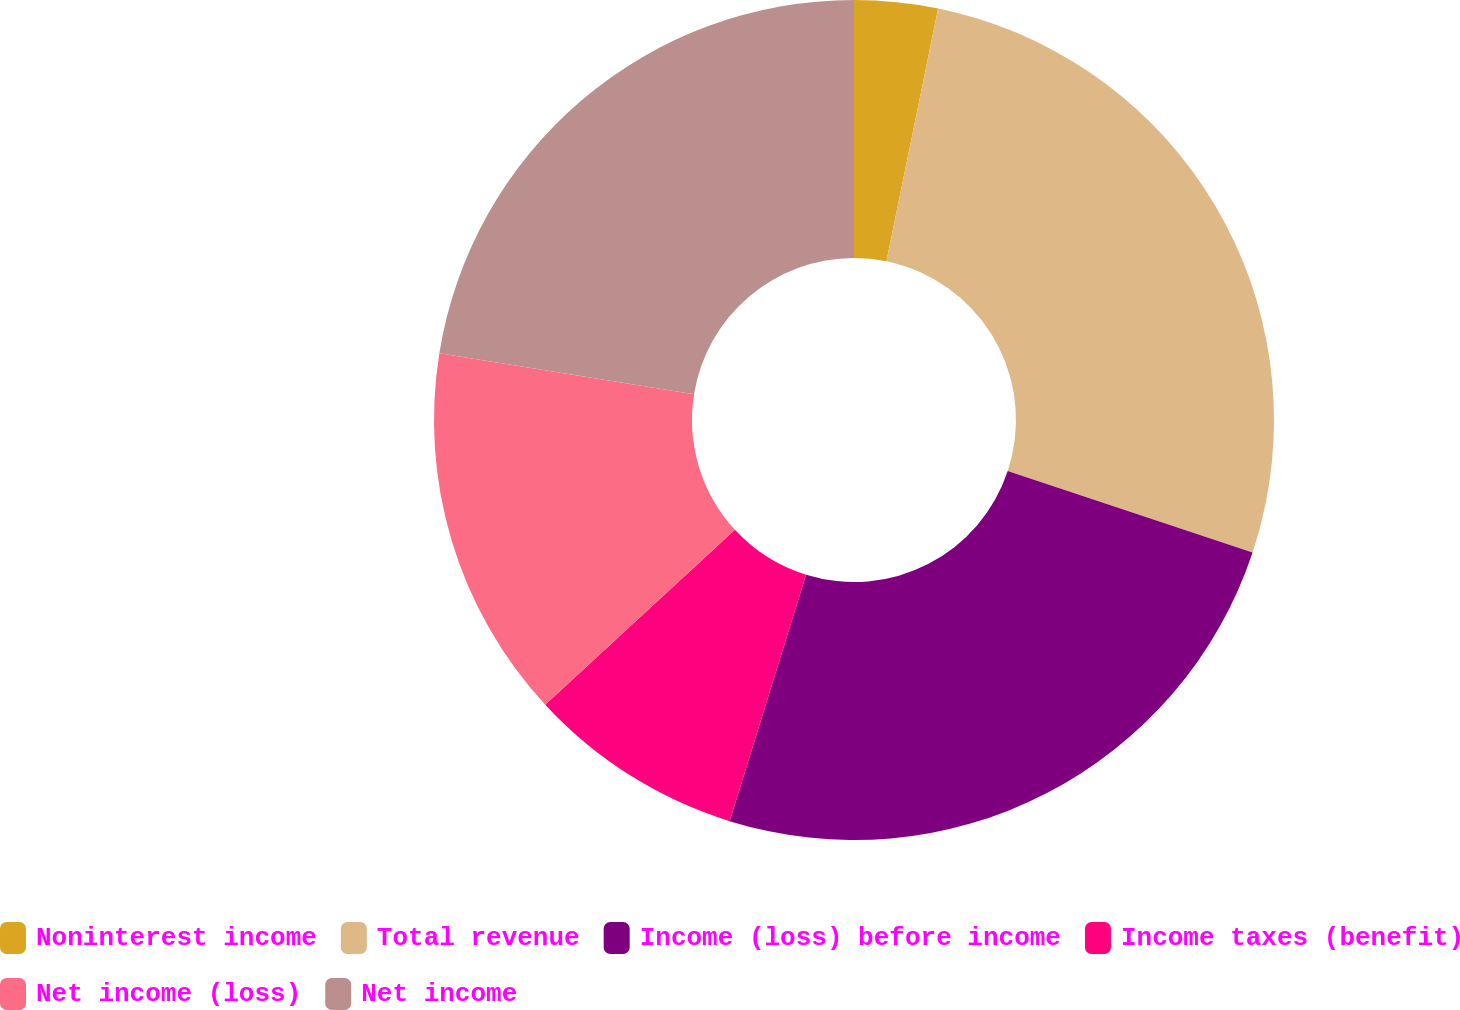Convert chart. <chart><loc_0><loc_0><loc_500><loc_500><pie_chart><fcel>Noninterest income<fcel>Total revenue<fcel>Income (loss) before income<fcel>Income taxes (benefit)<fcel>Net income (loss)<fcel>Net income<nl><fcel>3.21%<fcel>26.9%<fcel>24.68%<fcel>8.36%<fcel>14.4%<fcel>22.46%<nl></chart> 